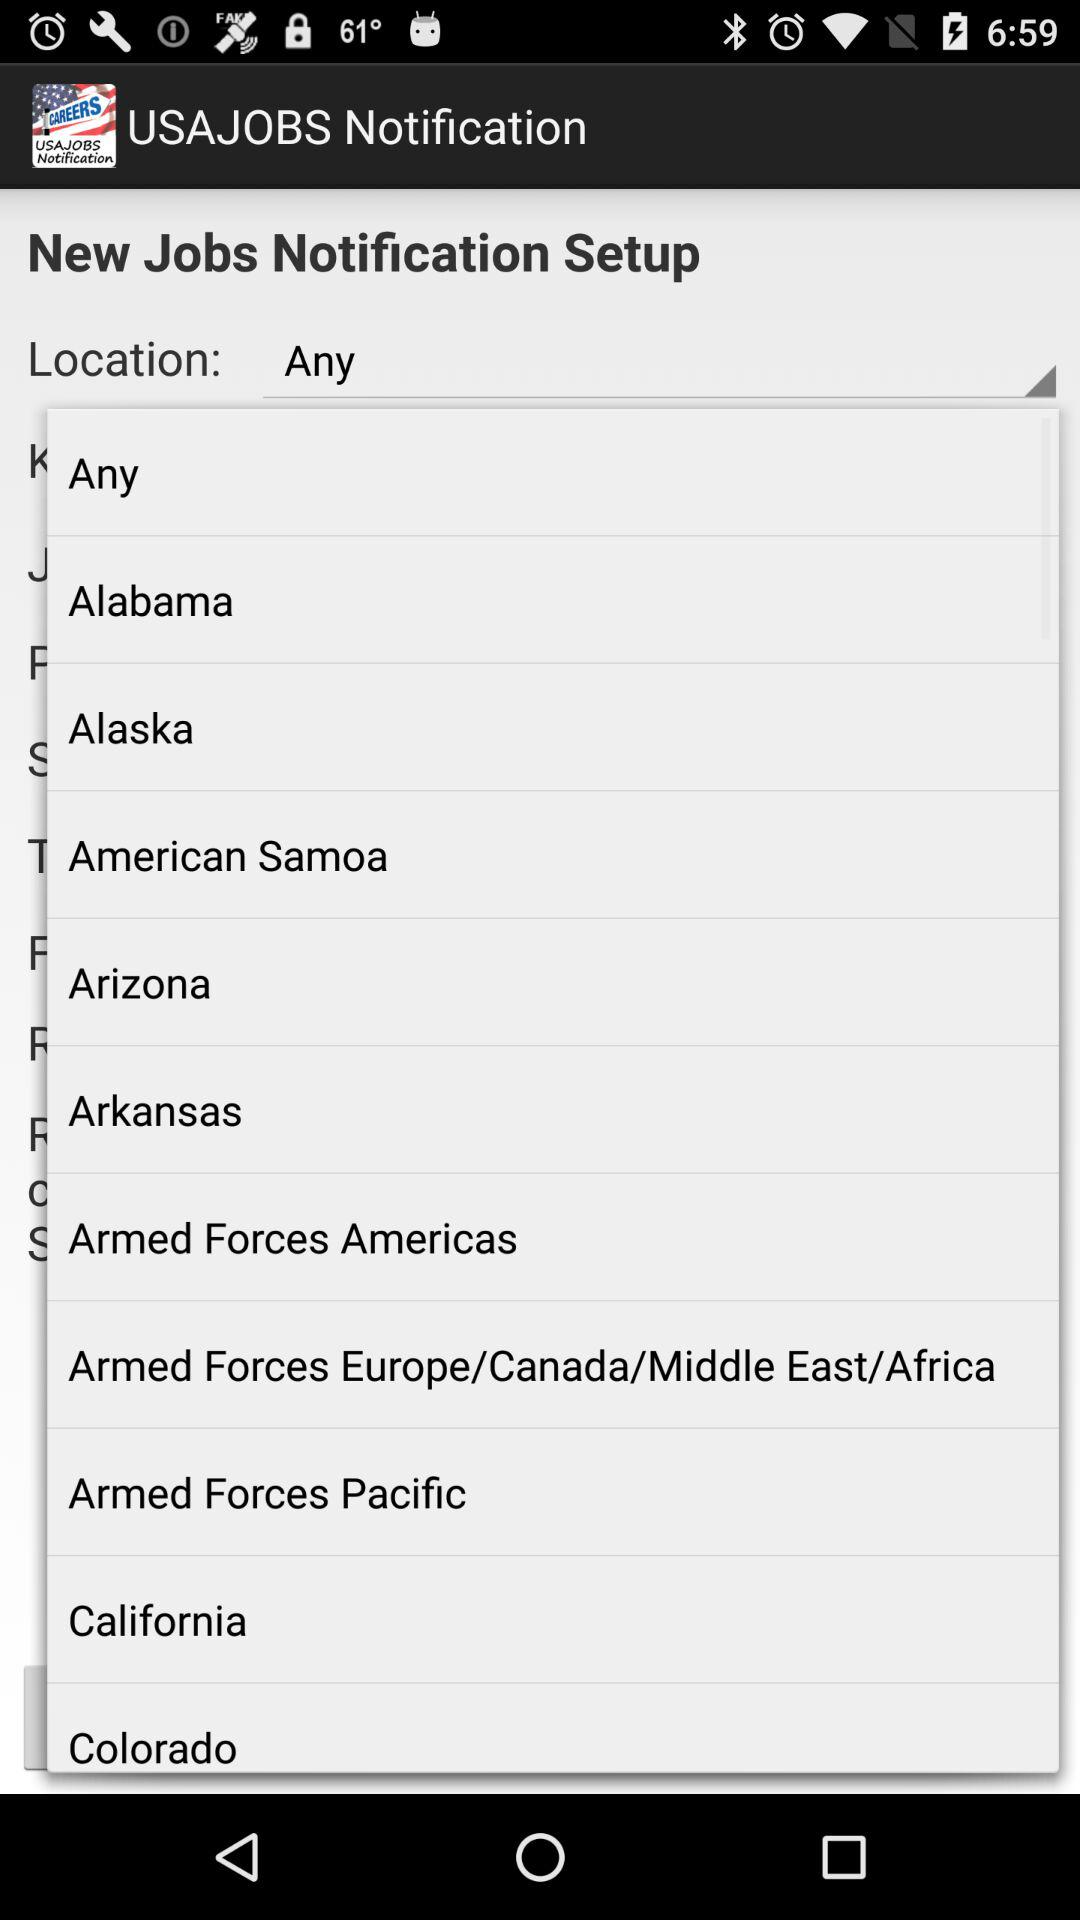What is the name of the application? The name of the application is "USAJOBS Notification". 